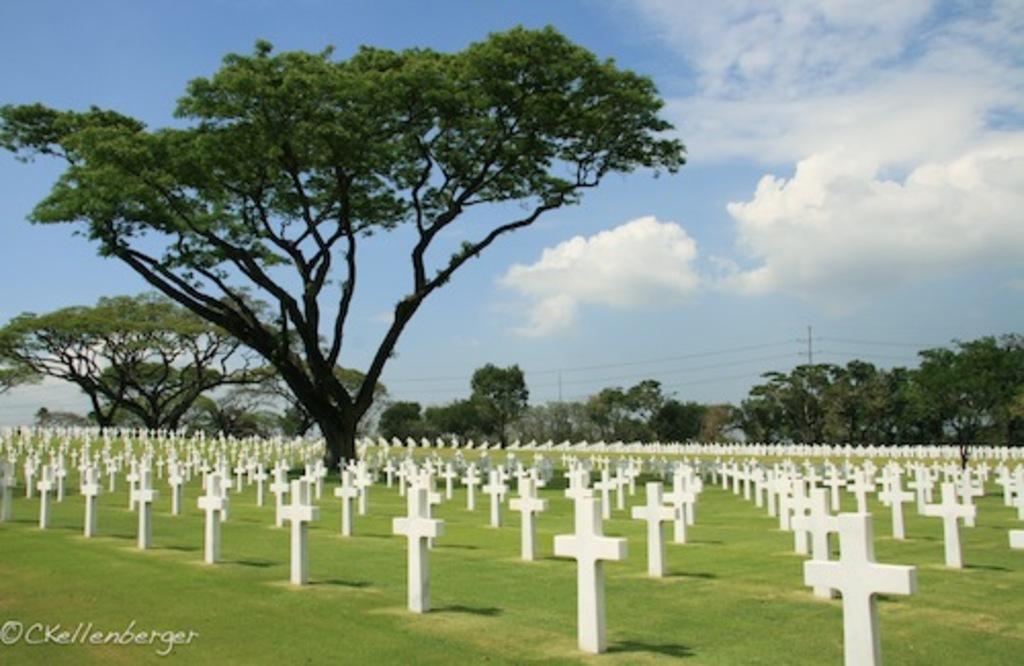How would you summarize this image in a sentence or two? In this picture I can see there is a graveyard and there is a tree here and there are many other trees, there is grass on the floor, there is a water mark at left bottom of the image. In the backdrop and there is a electric poles and the sky is clear. 